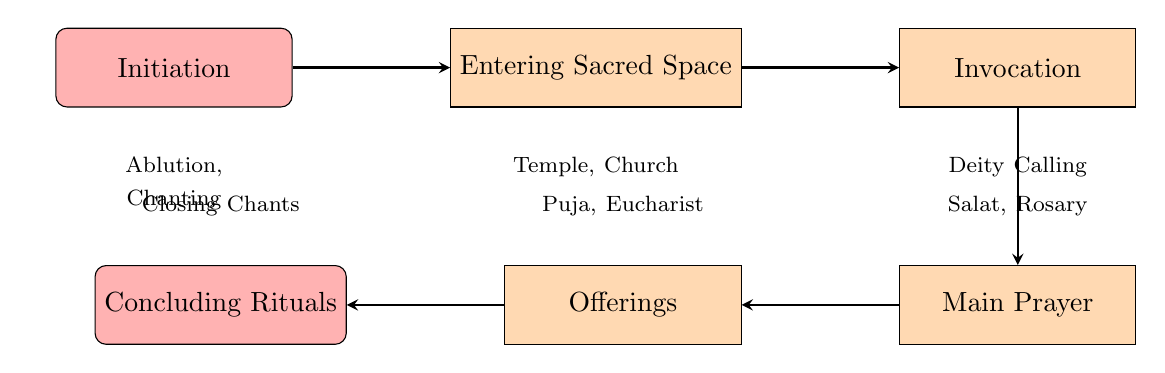What is the first node in the diagram? The first node in the flow chart is "Initiation." This is identified as it is the starting point of the process outlined in the diagram.
Answer: Initiation How many main nodes are present in the diagram? There are five main nodes represented in the diagram, which include "Initiation," "Entering Sacred Space," "Invocation," "Main Prayer," "Offerings," and "Concluding Rituals." Counting all of these gives a total of five nodes.
Answer: Five What is the relationship between "Main Prayer" and "Offerings"? "Main Prayer" leads to "Offerings" in the flow. This indicates the sequence of actions, where the practitioner first performs the main prayer before making offerings.
Answer: Main Prayer leads to Offerings Which node includes examples of "Salat" and "Rosary"? The node labeled "Main Prayer" includes examples such as "Islamic Salat" and "Christian Rosary Prayer." These examples are shown as illustrations of the types of prayers performed at that stage.
Answer: Main Prayer What is the final node of the prayer flow? The final node of the flow chart is "Concluding Rituals." This is the last step in the prayer process as illustrated by the direction of the arrows.
Answer: Concluding Rituals Which node comes before "Invocation"? The node that comes directly before "Invocation" is "Entering Sacred Space." This is determined by following the arrows from "Entering Sacred Space" to "Invocation" in the flow chart.
Answer: Entering Sacred Space How many offerings examples are provided in the diagram? Three examples are provided under the "Offerings" node, including "Hindu Puja Offerings," "Shinto Food Offerings," and "Christian Eucharist." This can be verified by counting the listed examples.
Answer: Three What type of act is performed in the "Concluding Rituals" node? The "Concluding Rituals" node involves acts like closing chants, meditation, or bowing. These actions represent the final steps to conclude the prayer session, as provided in the details of that node.
Answer: Closing chants, meditation, or bowing 